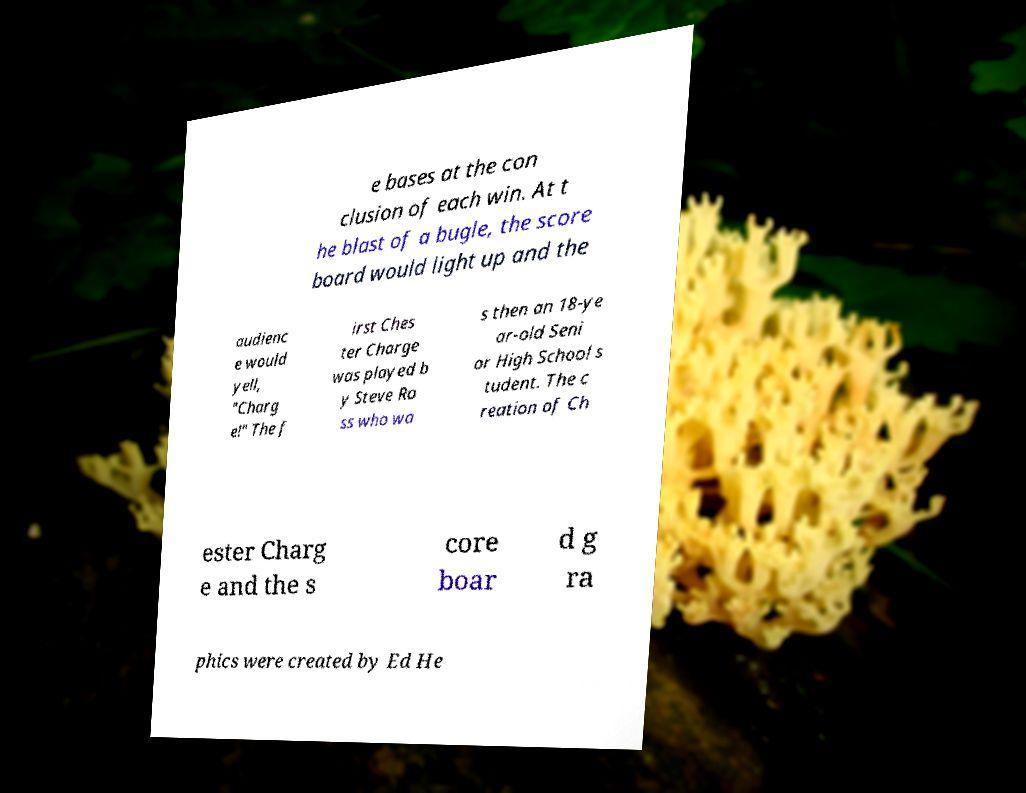Can you read and provide the text displayed in the image?This photo seems to have some interesting text. Can you extract and type it out for me? e bases at the con clusion of each win. At t he blast of a bugle, the score board would light up and the audienc e would yell, "Charg e!" The f irst Ches ter Charge was played b y Steve Ro ss who wa s then an 18-ye ar-old Seni or High School s tudent. The c reation of Ch ester Charg e and the s core boar d g ra phics were created by Ed He 